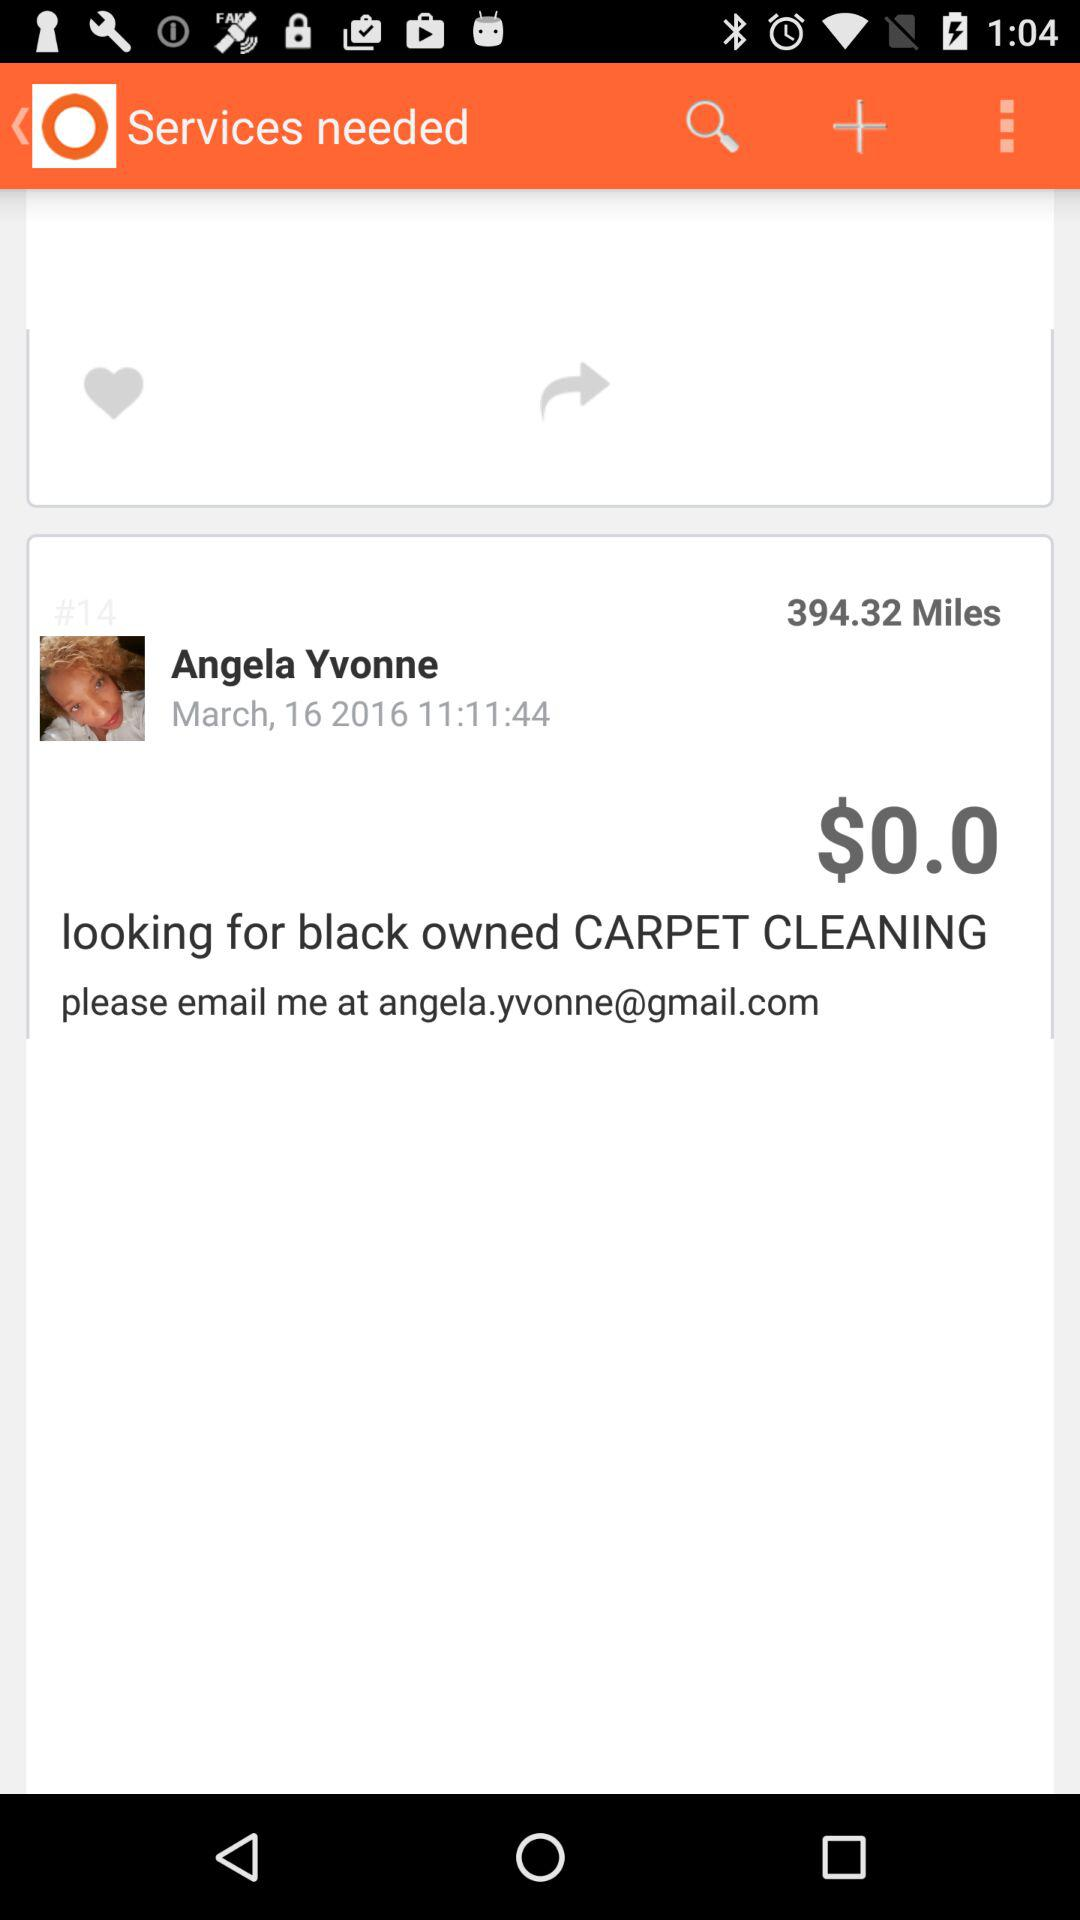What is the amount? The amount is $0.0. 